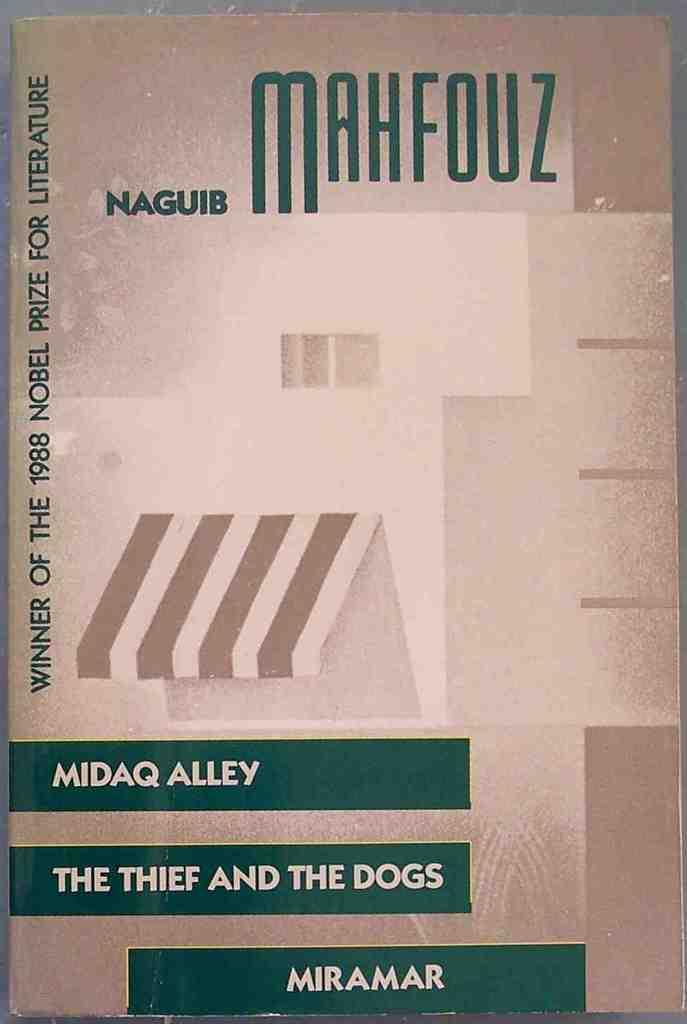Provide a one-sentence caption for the provided image. cover of Naguib Mahfouz book about Midaq Alley and the Thief and the dogs. 